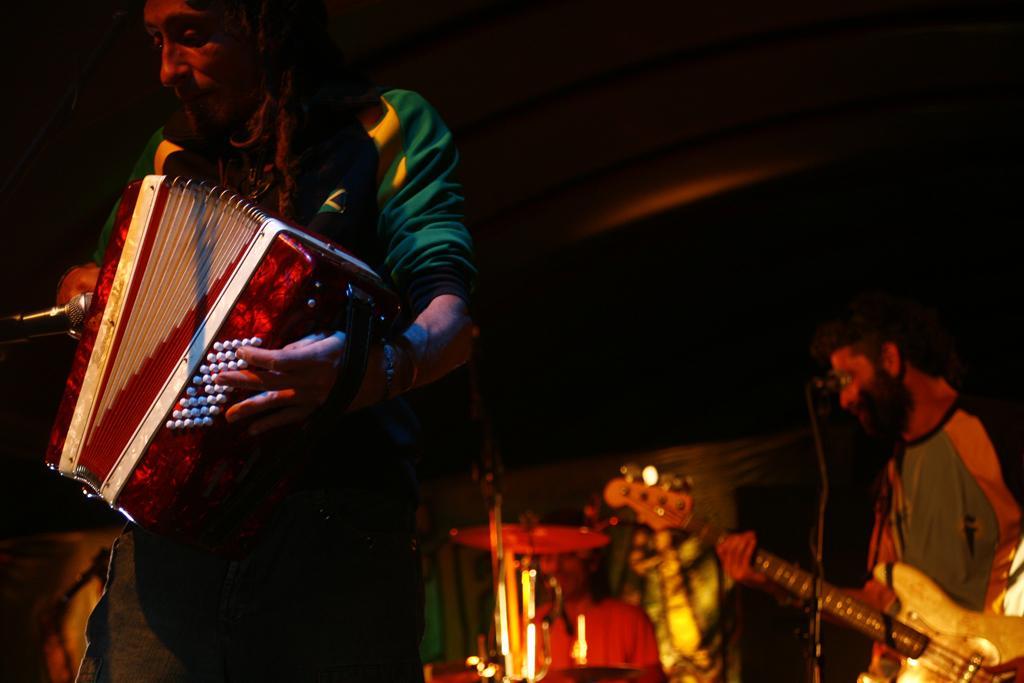In one or two sentences, can you explain what this image depicts? In this image there is a man in the foreground who is playing the accordion. In the background there is another man who is playing the guitar. Beside this man there is a person who is playing the drums. 